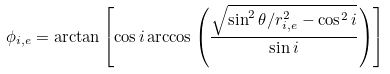<formula> <loc_0><loc_0><loc_500><loc_500>\phi _ { i , e } = \arctan \left [ \cos i \arccos \left ( \frac { \sqrt { \sin ^ { 2 } \theta / r _ { i , e } ^ { 2 } - \cos ^ { 2 } i } } { \sin i } \right ) \right ]</formula> 